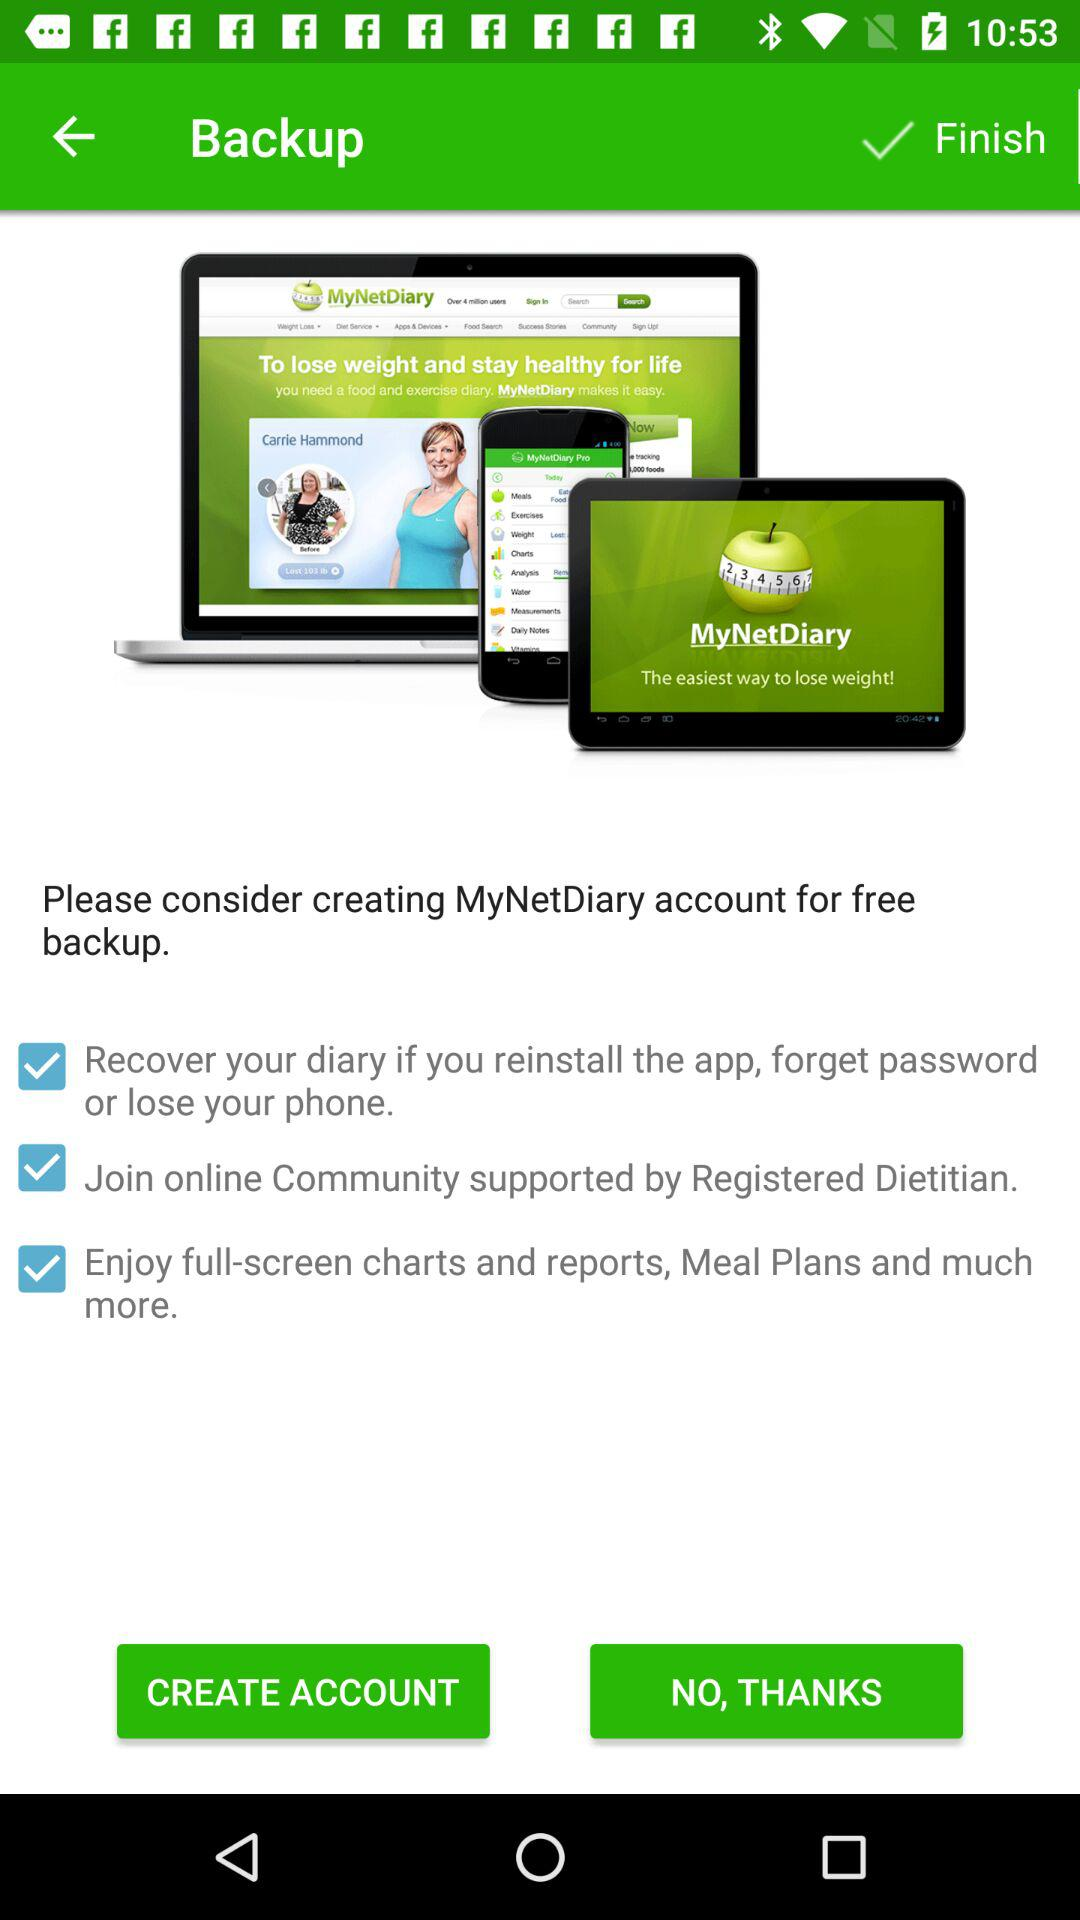What is the name of the application? The name of the application is "MyNetDiary". 